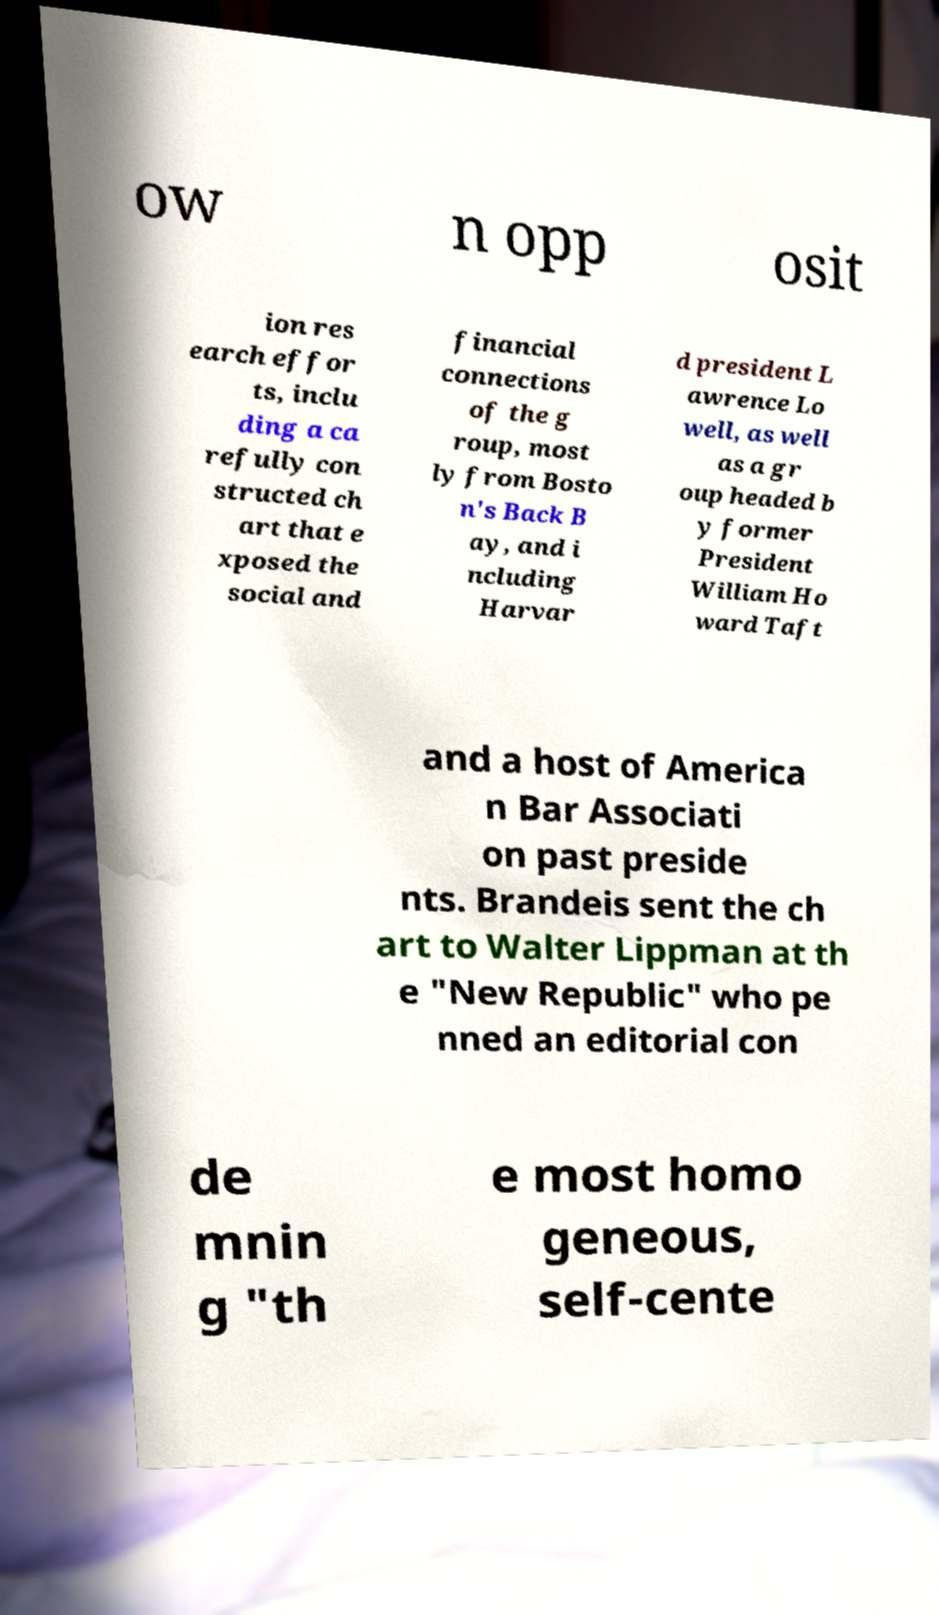Could you assist in decoding the text presented in this image and type it out clearly? ow n opp osit ion res earch effor ts, inclu ding a ca refully con structed ch art that e xposed the social and financial connections of the g roup, most ly from Bosto n's Back B ay, and i ncluding Harvar d president L awrence Lo well, as well as a gr oup headed b y former President William Ho ward Taft and a host of America n Bar Associati on past preside nts. Brandeis sent the ch art to Walter Lippman at th e "New Republic" who pe nned an editorial con de mnin g "th e most homo geneous, self-cente 